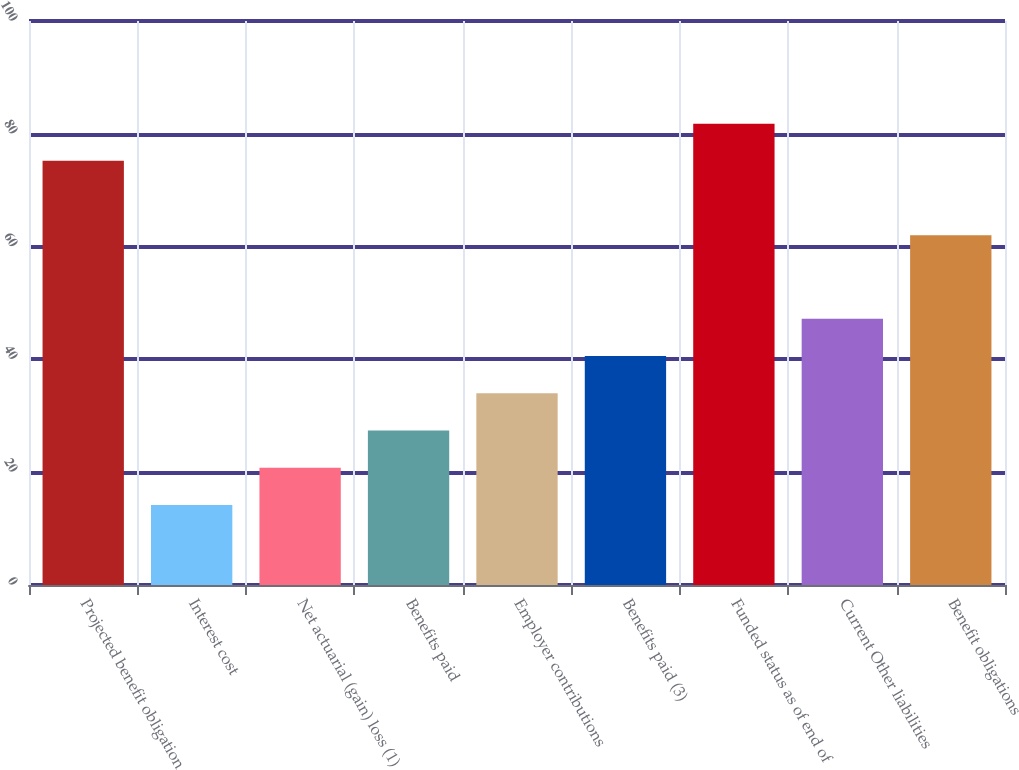Convert chart. <chart><loc_0><loc_0><loc_500><loc_500><bar_chart><fcel>Projected benefit obligation<fcel>Interest cost<fcel>Net actuarial (gain) loss (1)<fcel>Benefits paid<fcel>Employer contributions<fcel>Benefits paid (3)<fcel>Funded status as of end of<fcel>Current Other liabilities<fcel>Benefit obligations<nl><fcel>75.2<fcel>14.2<fcel>20.8<fcel>27.4<fcel>34<fcel>40.6<fcel>81.8<fcel>47.2<fcel>62<nl></chart> 